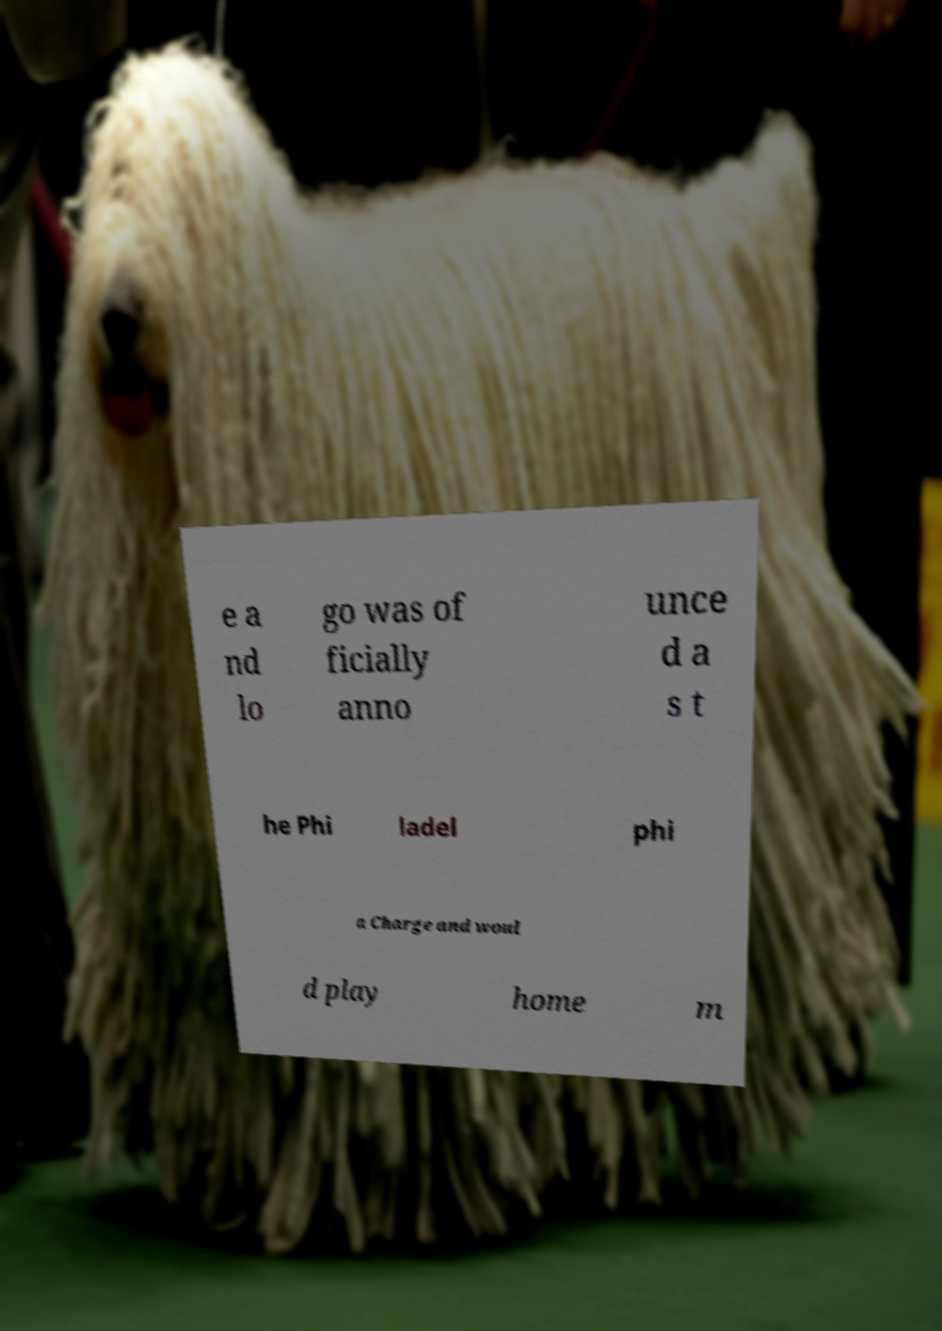Can you accurately transcribe the text from the provided image for me? e a nd lo go was of ficially anno unce d a s t he Phi ladel phi a Charge and woul d play home m 